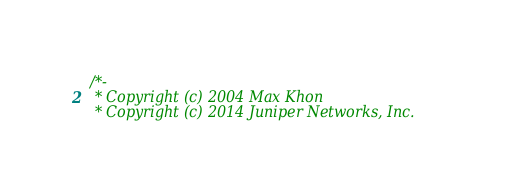<code> <loc_0><loc_0><loc_500><loc_500><_C_>/*-
 * Copyright (c) 2004 Max Khon
 * Copyright (c) 2014 Juniper Networks, Inc.</code> 